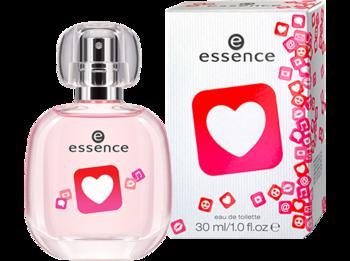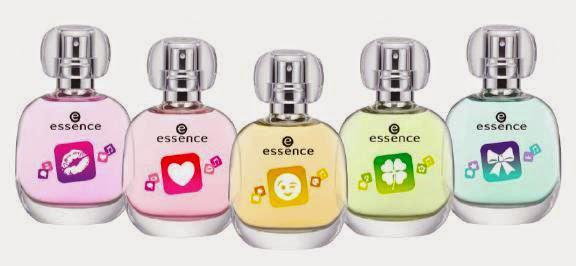The first image is the image on the left, the second image is the image on the right. Analyze the images presented: Is the assertion "there is only one cologne on the right image" valid? Answer yes or no. No. 